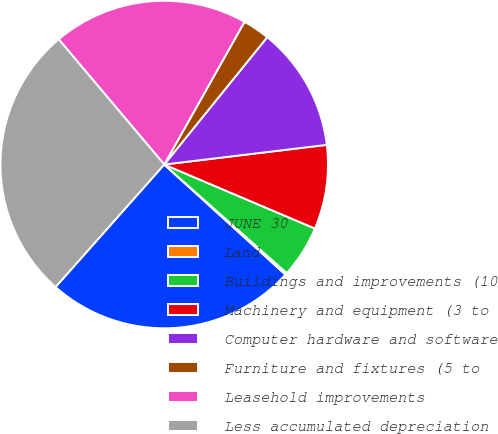Convert chart. <chart><loc_0><loc_0><loc_500><loc_500><pie_chart><fcel>JUNE 30<fcel>Land<fcel>Buildings and improvements (10<fcel>Machinery and equipment (3 to<fcel>Computer hardware and software<fcel>Furniture and fixtures (5 to<fcel>Leasehold improvements<fcel>Less accumulated depreciation<nl><fcel>24.82%<fcel>0.19%<fcel>5.15%<fcel>8.31%<fcel>12.26%<fcel>2.67%<fcel>19.3%<fcel>27.3%<nl></chart> 